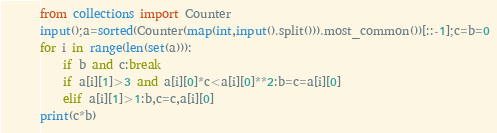Convert code to text. <code><loc_0><loc_0><loc_500><loc_500><_Python_>from collections import Counter
input();a=sorted(Counter(map(int,input().split())).most_common())[::-1];c=b=0
for i in range(len(set(a))):
    if b and c:break
    if a[i][1]>3 and a[i][0]*c<a[i][0]**2:b=c=a[i][0]
    elif a[i][1]>1:b,c=c,a[i][0]
print(c*b)</code> 